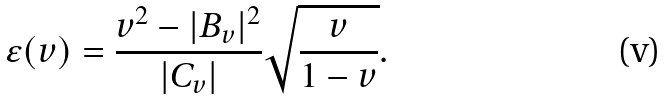<formula> <loc_0><loc_0><loc_500><loc_500>\varepsilon ( v ) = \frac { v ^ { 2 } - | B _ { v } | ^ { 2 } } { | C _ { v } | } \sqrt { \frac { v } { 1 - v } } .</formula> 